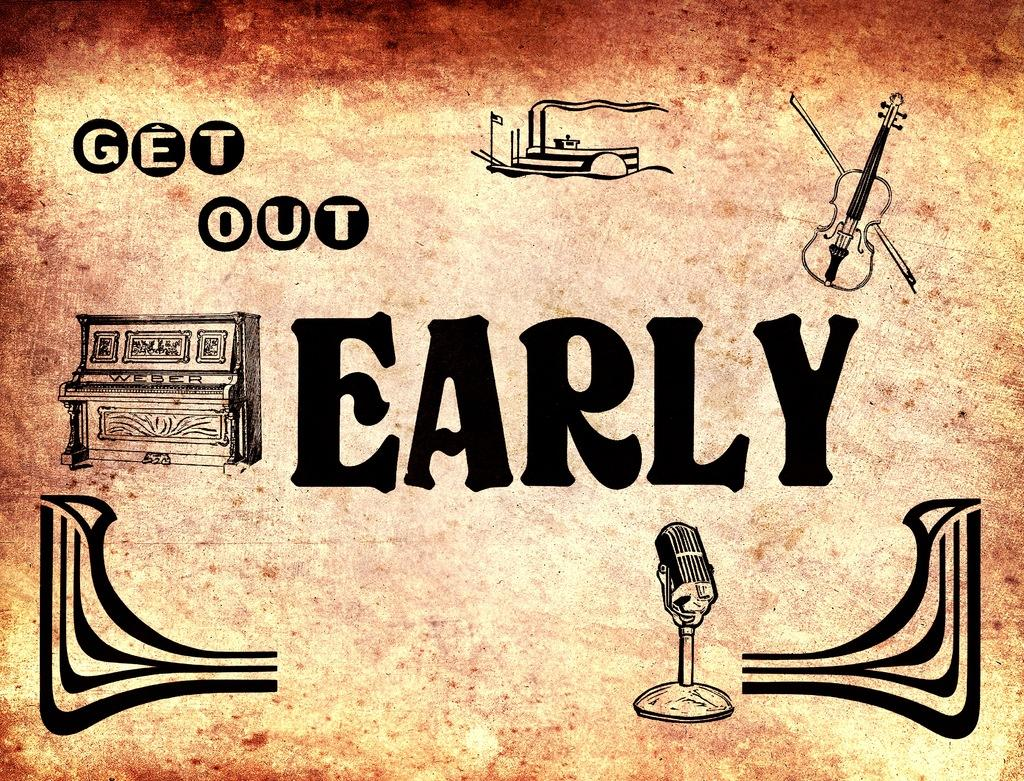What can be seen on the wall in the image? There is a poster in the image. What is featured on the poster? The poster contains text. What musical instruments are present in the image? There is a piano and a guitar in the image. What device is used for amplifying sound in the image? There is a microphone in the image. What else can be seen on the walls in the image? There are other paintings in the image. Is there a woman reading a book in the image? There is no woman or book present in the image. What is the position of the sun in the image? The image does not show the sun; it only features a poster, paintings, and musical instruments. 